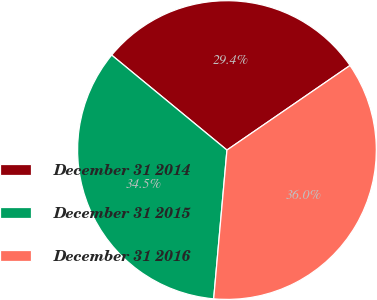<chart> <loc_0><loc_0><loc_500><loc_500><pie_chart><fcel>December 31 2014<fcel>December 31 2015<fcel>December 31 2016<nl><fcel>29.45%<fcel>34.55%<fcel>36.0%<nl></chart> 